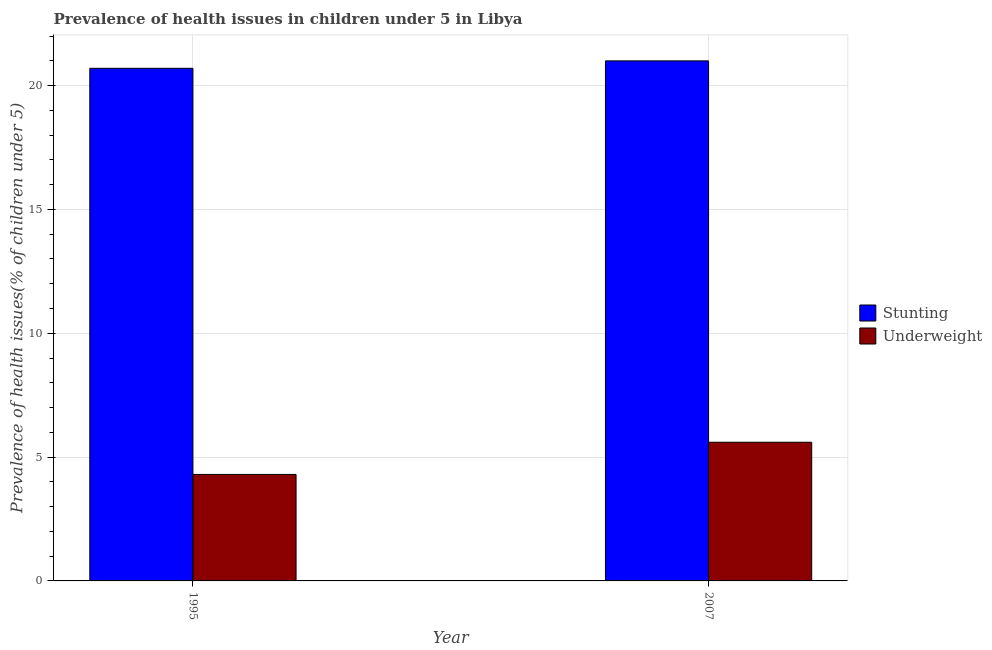How many groups of bars are there?
Make the answer very short. 2. Are the number of bars per tick equal to the number of legend labels?
Your answer should be compact. Yes. Are the number of bars on each tick of the X-axis equal?
Make the answer very short. Yes. How many bars are there on the 1st tick from the left?
Give a very brief answer. 2. In how many cases, is the number of bars for a given year not equal to the number of legend labels?
Provide a succinct answer. 0. What is the percentage of stunted children in 1995?
Ensure brevity in your answer.  20.7. Across all years, what is the maximum percentage of underweight children?
Keep it short and to the point. 5.6. Across all years, what is the minimum percentage of stunted children?
Provide a succinct answer. 20.7. In which year was the percentage of underweight children minimum?
Your answer should be very brief. 1995. What is the total percentage of underweight children in the graph?
Keep it short and to the point. 9.9. What is the difference between the percentage of stunted children in 1995 and that in 2007?
Ensure brevity in your answer.  -0.3. What is the difference between the percentage of stunted children in 1995 and the percentage of underweight children in 2007?
Provide a short and direct response. -0.3. What is the average percentage of underweight children per year?
Offer a very short reply. 4.95. In how many years, is the percentage of underweight children greater than 14 %?
Provide a short and direct response. 0. What is the ratio of the percentage of underweight children in 1995 to that in 2007?
Your answer should be compact. 0.77. Is the percentage of stunted children in 1995 less than that in 2007?
Your answer should be very brief. Yes. In how many years, is the percentage of underweight children greater than the average percentage of underweight children taken over all years?
Ensure brevity in your answer.  1. What does the 2nd bar from the left in 2007 represents?
Your answer should be compact. Underweight. What does the 2nd bar from the right in 2007 represents?
Your answer should be very brief. Stunting. Are all the bars in the graph horizontal?
Provide a short and direct response. No. What is the difference between two consecutive major ticks on the Y-axis?
Your answer should be very brief. 5. Are the values on the major ticks of Y-axis written in scientific E-notation?
Your answer should be very brief. No. Does the graph contain any zero values?
Offer a terse response. No. Does the graph contain grids?
Your answer should be very brief. Yes. Where does the legend appear in the graph?
Ensure brevity in your answer.  Center right. How are the legend labels stacked?
Provide a succinct answer. Vertical. What is the title of the graph?
Your answer should be very brief. Prevalence of health issues in children under 5 in Libya. Does "Urban" appear as one of the legend labels in the graph?
Offer a terse response. No. What is the label or title of the X-axis?
Your answer should be very brief. Year. What is the label or title of the Y-axis?
Provide a short and direct response. Prevalence of health issues(% of children under 5). What is the Prevalence of health issues(% of children under 5) in Stunting in 1995?
Offer a very short reply. 20.7. What is the Prevalence of health issues(% of children under 5) in Underweight in 1995?
Your answer should be very brief. 4.3. What is the Prevalence of health issues(% of children under 5) in Stunting in 2007?
Keep it short and to the point. 21. What is the Prevalence of health issues(% of children under 5) in Underweight in 2007?
Provide a succinct answer. 5.6. Across all years, what is the maximum Prevalence of health issues(% of children under 5) of Stunting?
Make the answer very short. 21. Across all years, what is the maximum Prevalence of health issues(% of children under 5) in Underweight?
Your response must be concise. 5.6. Across all years, what is the minimum Prevalence of health issues(% of children under 5) in Stunting?
Provide a succinct answer. 20.7. Across all years, what is the minimum Prevalence of health issues(% of children under 5) of Underweight?
Ensure brevity in your answer.  4.3. What is the total Prevalence of health issues(% of children under 5) of Stunting in the graph?
Keep it short and to the point. 41.7. What is the total Prevalence of health issues(% of children under 5) of Underweight in the graph?
Your answer should be very brief. 9.9. What is the difference between the Prevalence of health issues(% of children under 5) in Underweight in 1995 and that in 2007?
Give a very brief answer. -1.3. What is the difference between the Prevalence of health issues(% of children under 5) in Stunting in 1995 and the Prevalence of health issues(% of children under 5) in Underweight in 2007?
Your response must be concise. 15.1. What is the average Prevalence of health issues(% of children under 5) of Stunting per year?
Offer a terse response. 20.85. What is the average Prevalence of health issues(% of children under 5) of Underweight per year?
Provide a succinct answer. 4.95. In the year 2007, what is the difference between the Prevalence of health issues(% of children under 5) of Stunting and Prevalence of health issues(% of children under 5) of Underweight?
Your answer should be very brief. 15.4. What is the ratio of the Prevalence of health issues(% of children under 5) in Stunting in 1995 to that in 2007?
Your response must be concise. 0.99. What is the ratio of the Prevalence of health issues(% of children under 5) in Underweight in 1995 to that in 2007?
Provide a short and direct response. 0.77. What is the difference between the highest and the second highest Prevalence of health issues(% of children under 5) of Stunting?
Keep it short and to the point. 0.3. What is the difference between the highest and the lowest Prevalence of health issues(% of children under 5) of Stunting?
Give a very brief answer. 0.3. What is the difference between the highest and the lowest Prevalence of health issues(% of children under 5) of Underweight?
Offer a terse response. 1.3. 